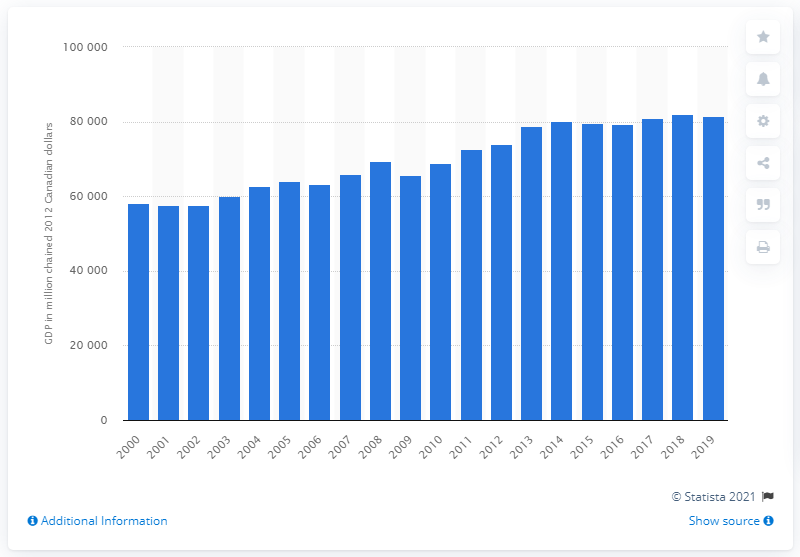Point out several critical features in this image. In the year 2012, the gross domestic product (GDP) of Saskatchewan was 81,540.7 Canadian dollars. 